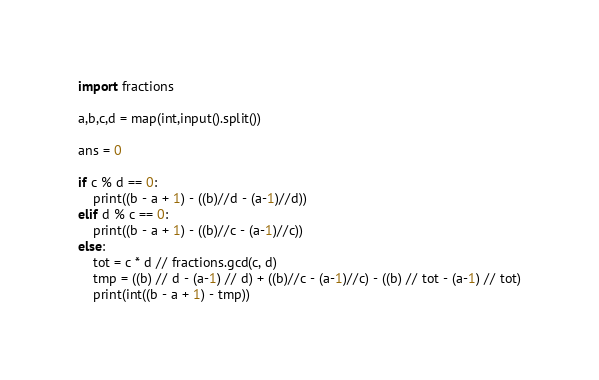Convert code to text. <code><loc_0><loc_0><loc_500><loc_500><_Python_>import fractions

a,b,c,d = map(int,input().split())

ans = 0

if c % d == 0:
    print((b - a + 1) - ((b)//d - (a-1)//d))
elif d % c == 0:
    print((b - a + 1) - ((b)//c - (a-1)//c))
else:
    tot = c * d // fractions.gcd(c, d)
    tmp = ((b) // d - (a-1) // d) + ((b)//c - (a-1)//c) - ((b) // tot - (a-1) // tot)
    print(int((b - a + 1) - tmp))</code> 